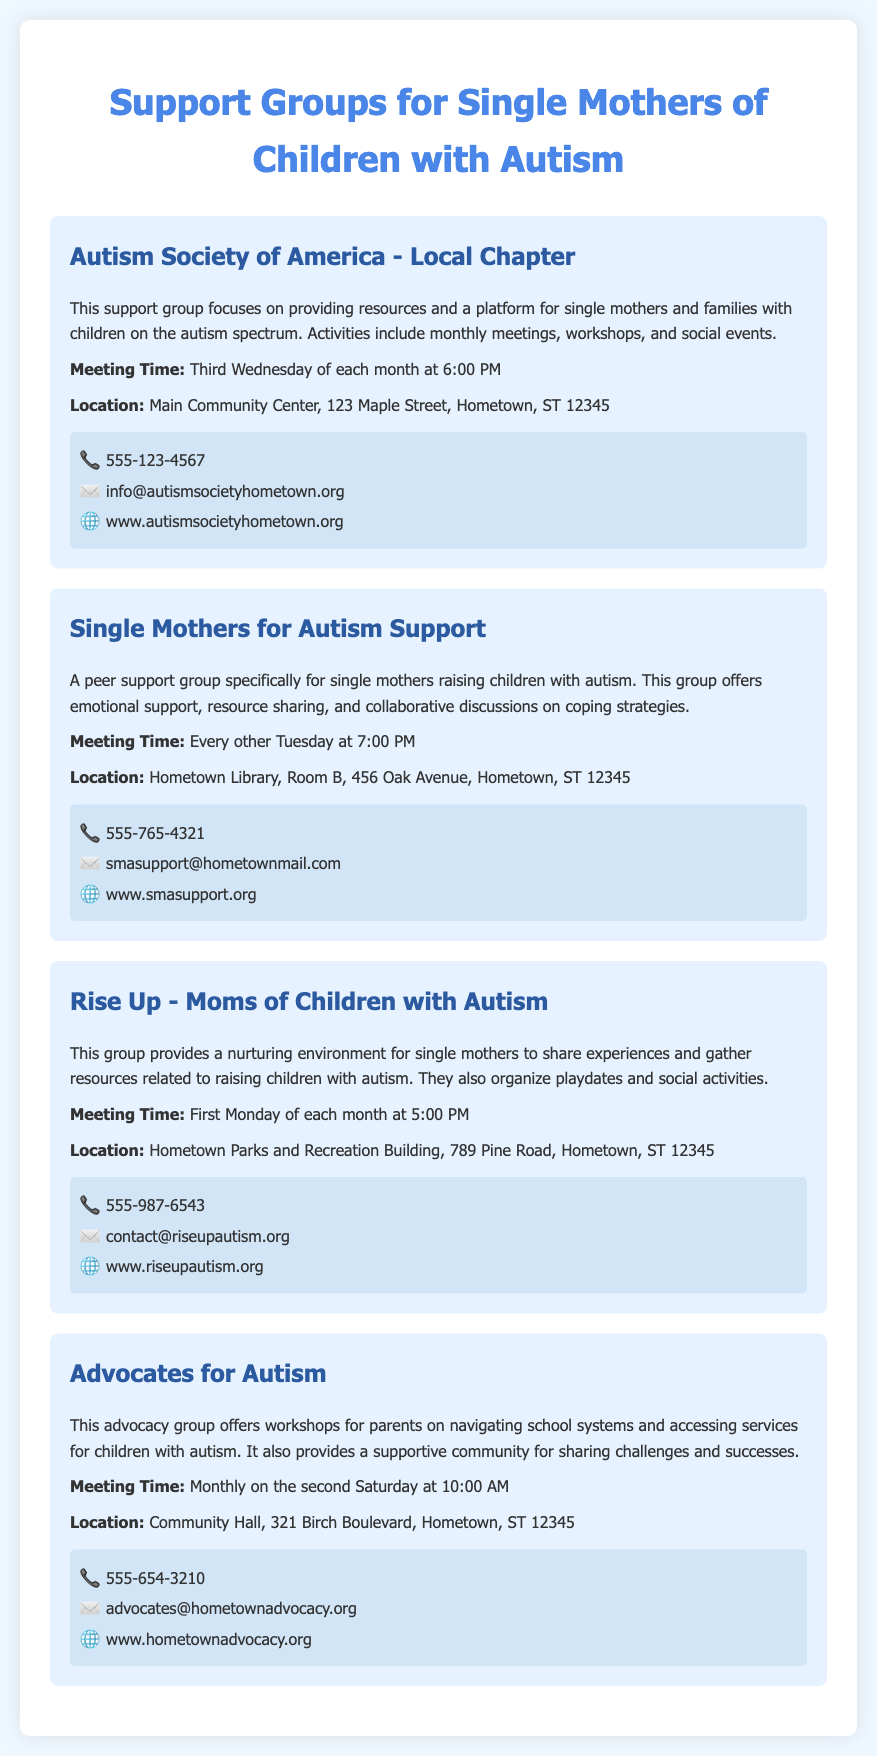What is the name of the first support group listed? The first support group mentioned in the document is the "Autism Society of America - Local Chapter."
Answer: Autism Society of America - Local Chapter When does the Autism Society of America group meet? The meeting time for the Autism Society of America is on the "Third Wednesday of each month at 6:00 PM."
Answer: Third Wednesday of each month at 6:00 PM What is the location of the "Single Mothers for Autism Support" group? The document specifies that the "Single Mothers for Autism Support" group meets at "Hometown Library, Room B, 456 Oak Avenue, Hometown, ST 12345."
Answer: Hometown Library, Room B, 456 Oak Avenue, Hometown, ST 12345 How often does the "Rise Up - Moms of Children with Autism" group hold meetings? The document indicates that the "Rise Up" group meets "First Monday of each month."
Answer: First Monday of each month What type of support does the "Advocates for Autism" group provide? The "Advocates for Autism" group offers "workshops for parents on navigating school systems and accessing services."
Answer: Workshops for parents on navigating school systems and accessing services What is the contact email for the "Single Mothers for Autism Support" group? The email provided for the "Single Mothers for Autism Support" group is "smasupport@hometownmail.com."
Answer: smasupport@hometownmail.com What is the contact number for the "Rise Up - Moms of Children with Autism"? The contact number listed for the "Rise Up" group is "555-987-6543."
Answer: 555-987-6543 What community event does the Autism Society organize? The Autism Society organizes "monthly meetings, workshops, and social events."
Answer: Monthly meetings, workshops, and social events How does the content address the needs of single mothers? The content focuses on providing "emotional support, resource sharing, and collaborative discussions" for single mothers.
Answer: Emotional support, resource sharing, and collaborative discussions 